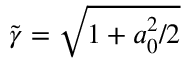<formula> <loc_0><loc_0><loc_500><loc_500>\tilde { \gamma } = \sqrt { 1 + a _ { 0 } ^ { 2 } / 2 }</formula> 